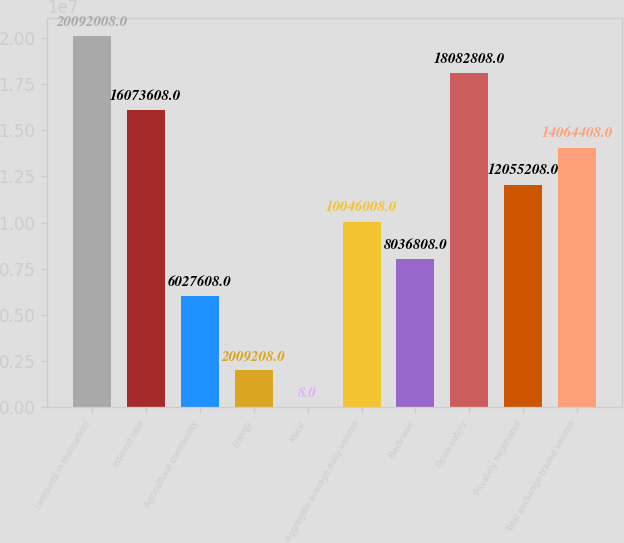<chart> <loc_0><loc_0><loc_500><loc_500><bar_chart><fcel>(amounts in thousands)<fcel>Interest rate<fcel>Agricultural commodity<fcel>Energy<fcel>Metal<fcel>Aggregate average daily volume<fcel>Electronic<fcel>Open outcry<fcel>Privately negotiated<fcel>Total exchange-traded volume<nl><fcel>2.0092e+07<fcel>1.60736e+07<fcel>6.02761e+06<fcel>2.00921e+06<fcel>8<fcel>1.0046e+07<fcel>8.03681e+06<fcel>1.80828e+07<fcel>1.20552e+07<fcel>1.40644e+07<nl></chart> 